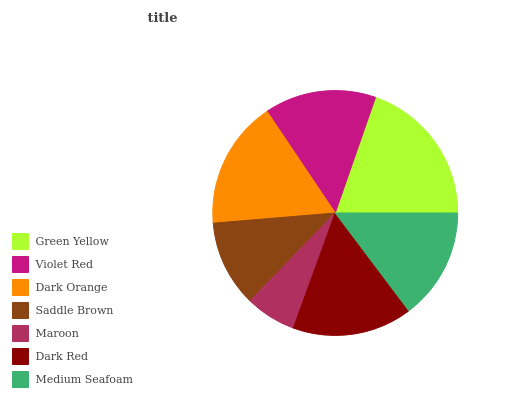Is Maroon the minimum?
Answer yes or no. Yes. Is Green Yellow the maximum?
Answer yes or no. Yes. Is Violet Red the minimum?
Answer yes or no. No. Is Violet Red the maximum?
Answer yes or no. No. Is Green Yellow greater than Violet Red?
Answer yes or no. Yes. Is Violet Red less than Green Yellow?
Answer yes or no. Yes. Is Violet Red greater than Green Yellow?
Answer yes or no. No. Is Green Yellow less than Violet Red?
Answer yes or no. No. Is Violet Red the high median?
Answer yes or no. Yes. Is Violet Red the low median?
Answer yes or no. Yes. Is Maroon the high median?
Answer yes or no. No. Is Maroon the low median?
Answer yes or no. No. 